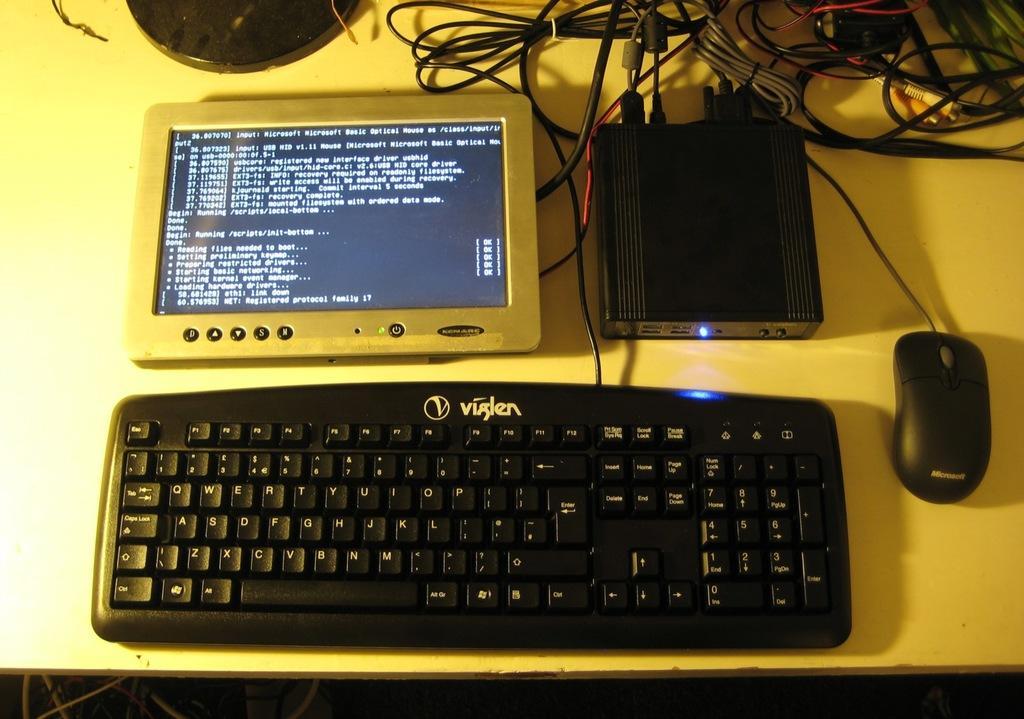Please provide a concise description of this image. In this image there is a table. On the table there is a keyboard. There is a mouse and there are other objects. There are wires at the top of the image. 